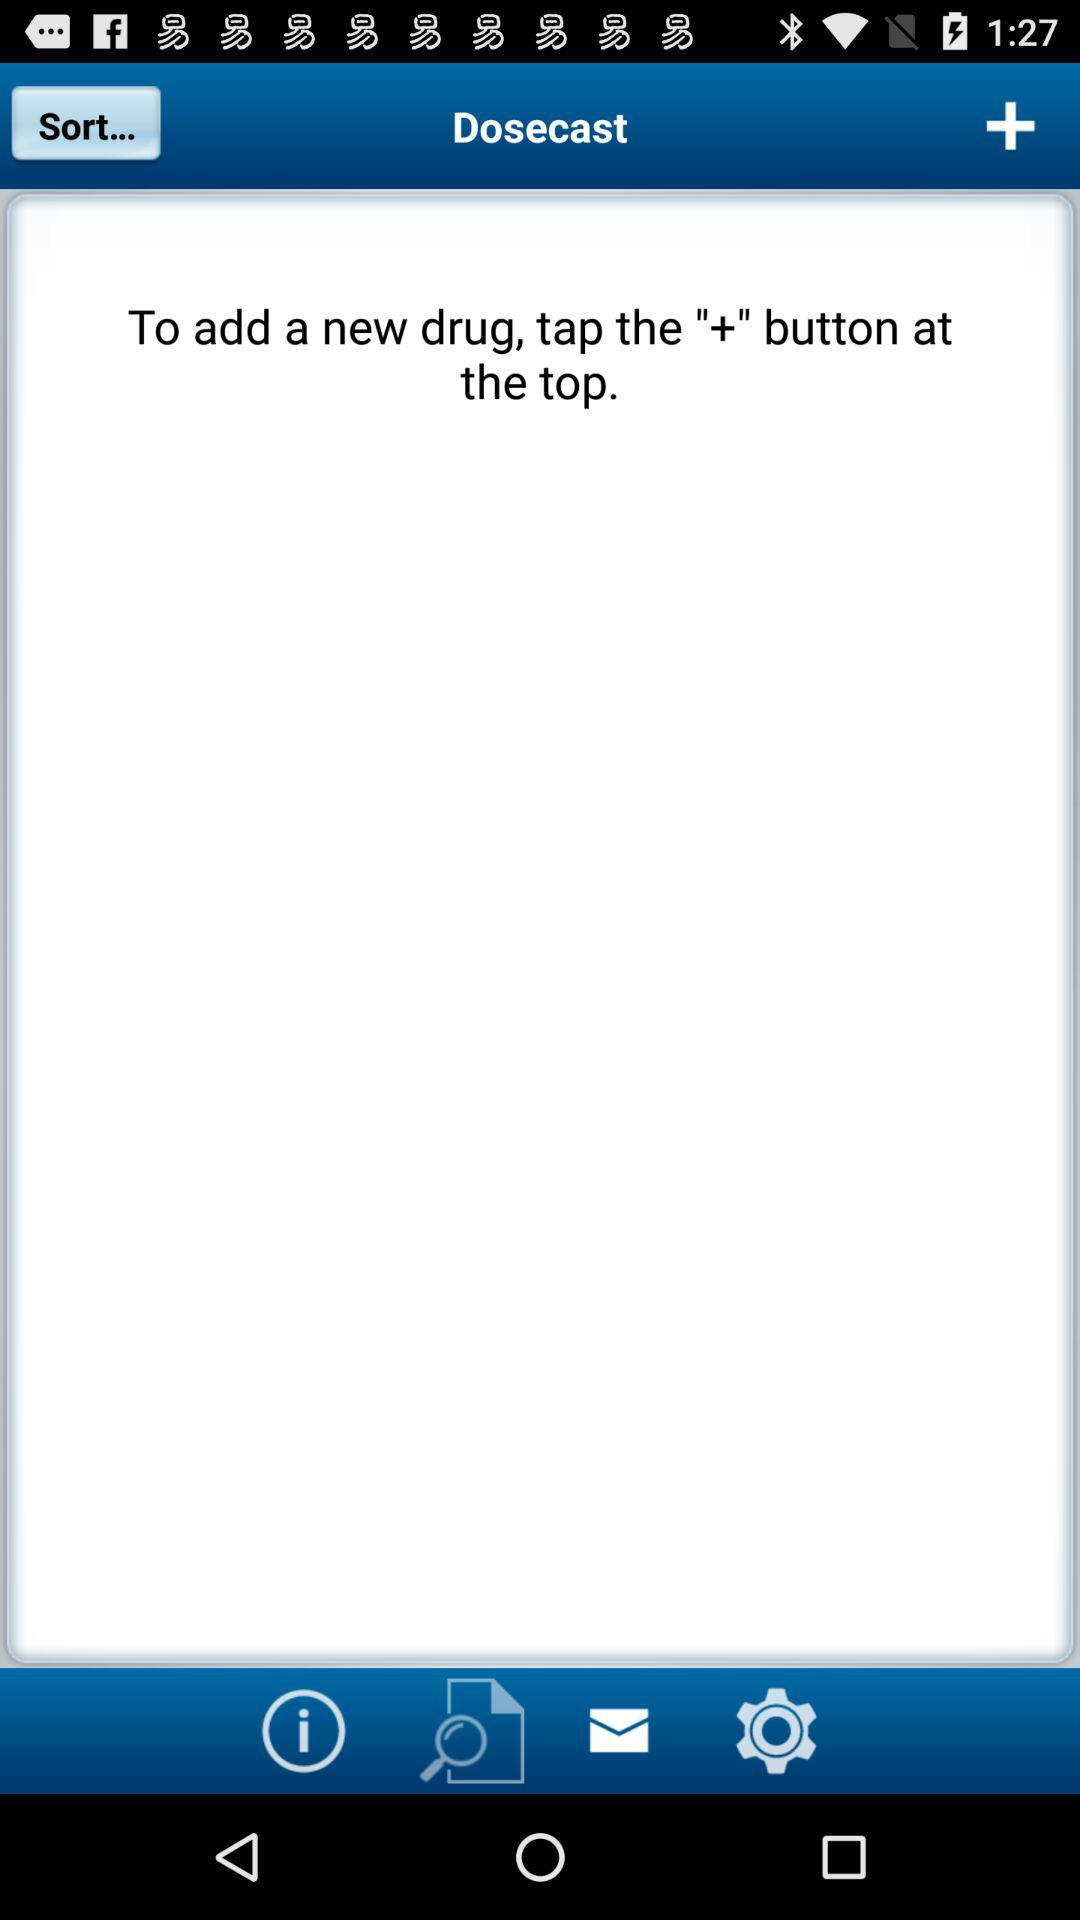What button do we need to tap to add a new drug? You need to tap the "+" button to add a new drug. 